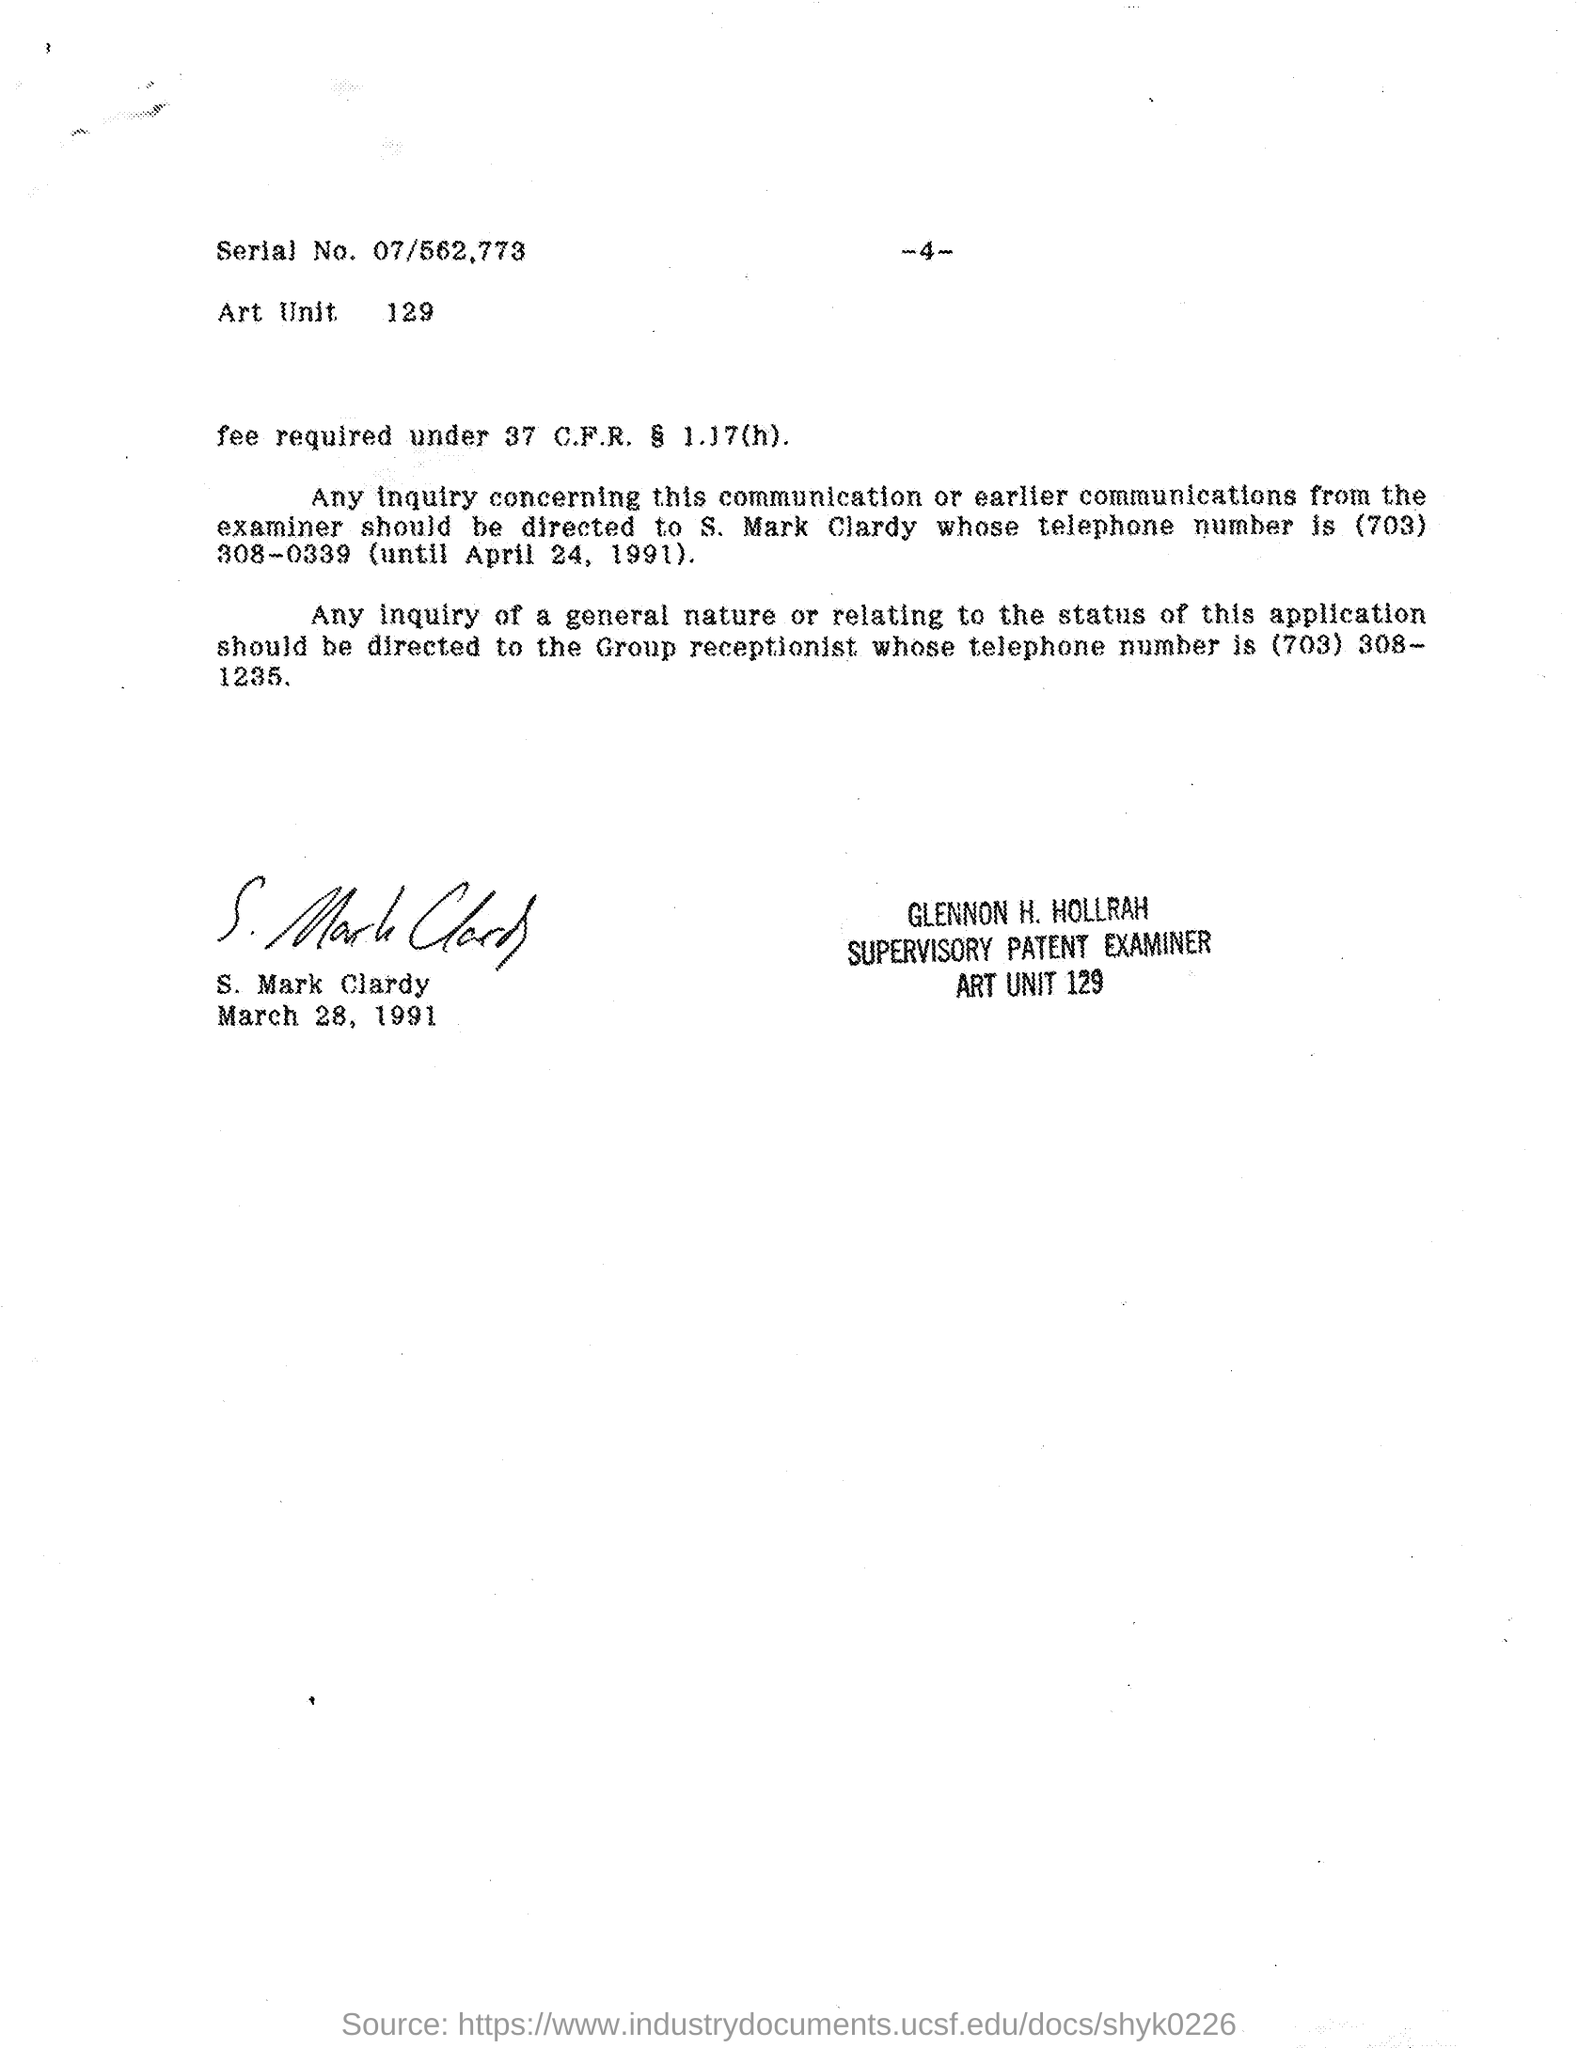What is the serial no. mentioned in the given page ?
Offer a very short reply. 07/562.773. What is the art unit number mentioned in the given page ?
Your answer should be compact. 129. What is the telephone number of s. mark clardy mentioned in the given page ?
Give a very brief answer. (703) 308-0339. What is the telephone number of group receptionist mentioned in the given letter ?
Provide a succinct answer. (703) 308-1235. What is the designation of glennon h. hollrah ?
Provide a short and direct response. Supervisory Patent Examiner. Who's sign was there at the end of the letter ?
Make the answer very short. S. Mark Clardy. 